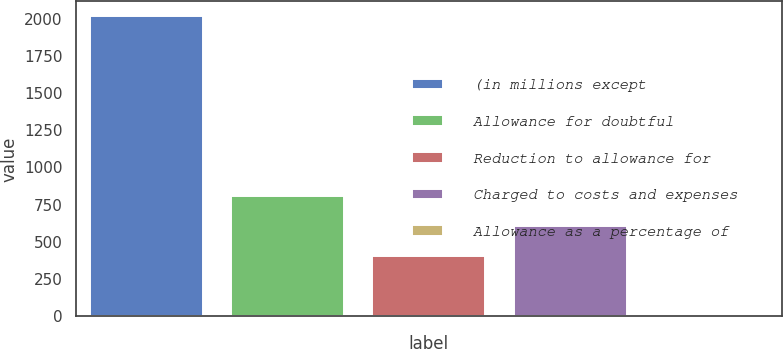Convert chart. <chart><loc_0><loc_0><loc_500><loc_500><bar_chart><fcel>(in millions except<fcel>Allowance for doubtful<fcel>Reduction to allowance for<fcel>Charged to costs and expenses<fcel>Allowance as a percentage of<nl><fcel>2014<fcel>805.69<fcel>402.93<fcel>604.31<fcel>0.17<nl></chart> 